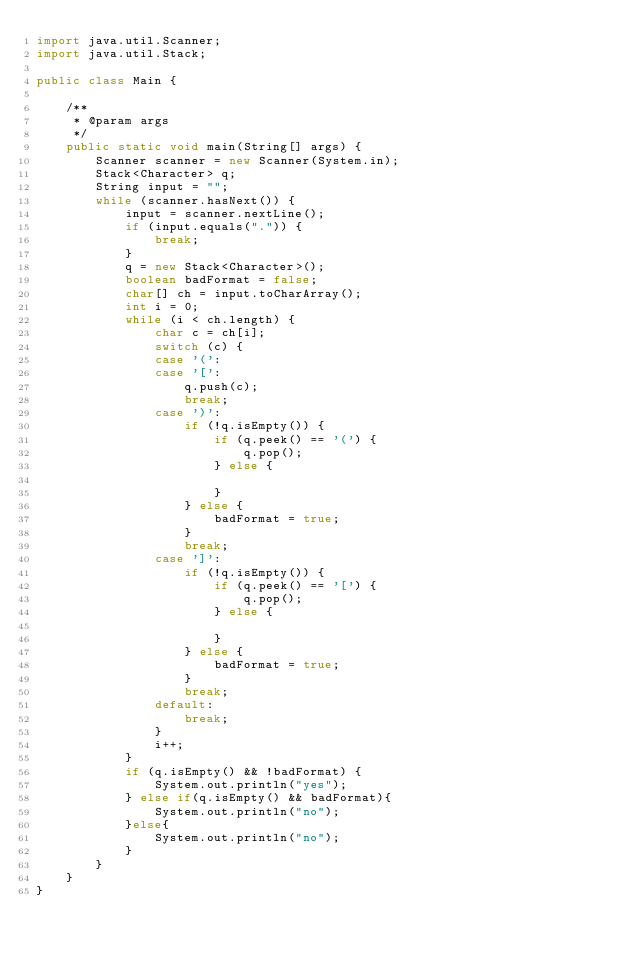Convert code to text. <code><loc_0><loc_0><loc_500><loc_500><_Java_>import java.util.Scanner;
import java.util.Stack;

public class Main {

	/**
	 * @param args
	 */
	public static void main(String[] args) {
		Scanner scanner = new Scanner(System.in);
		Stack<Character> q;
		String input = "";
		while (scanner.hasNext()) {
			input = scanner.nextLine();
			if (input.equals(".")) {
				break;
			}
			q = new Stack<Character>();
			boolean badFormat = false;
			char[] ch = input.toCharArray();
			int i = 0;
			while (i < ch.length) {
				char c = ch[i];
				switch (c) {
				case '(':
				case '[':
					q.push(c);
					break;
				case ')':
					if (!q.isEmpty()) {
						if (q.peek() == '(') {
							q.pop();
						} else {

						}
					} else {
						badFormat = true;
					}
					break;
				case ']':
					if (!q.isEmpty()) {
						if (q.peek() == '[') {
							q.pop();
						} else {

						}
					} else {
						badFormat = true;
					}
					break;
				default:
					break;
				}
				i++;
			}
			if (q.isEmpty() && !badFormat) {
				System.out.println("yes");
			} else if(q.isEmpty() && badFormat){
				System.out.println("no");
			}else{
				System.out.println("no");
			}
		}
	}
}</code> 